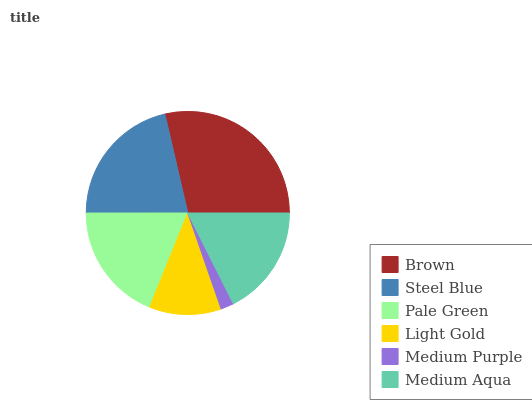Is Medium Purple the minimum?
Answer yes or no. Yes. Is Brown the maximum?
Answer yes or no. Yes. Is Steel Blue the minimum?
Answer yes or no. No. Is Steel Blue the maximum?
Answer yes or no. No. Is Brown greater than Steel Blue?
Answer yes or no. Yes. Is Steel Blue less than Brown?
Answer yes or no. Yes. Is Steel Blue greater than Brown?
Answer yes or no. No. Is Brown less than Steel Blue?
Answer yes or no. No. Is Pale Green the high median?
Answer yes or no. Yes. Is Medium Aqua the low median?
Answer yes or no. Yes. Is Steel Blue the high median?
Answer yes or no. No. Is Medium Purple the low median?
Answer yes or no. No. 